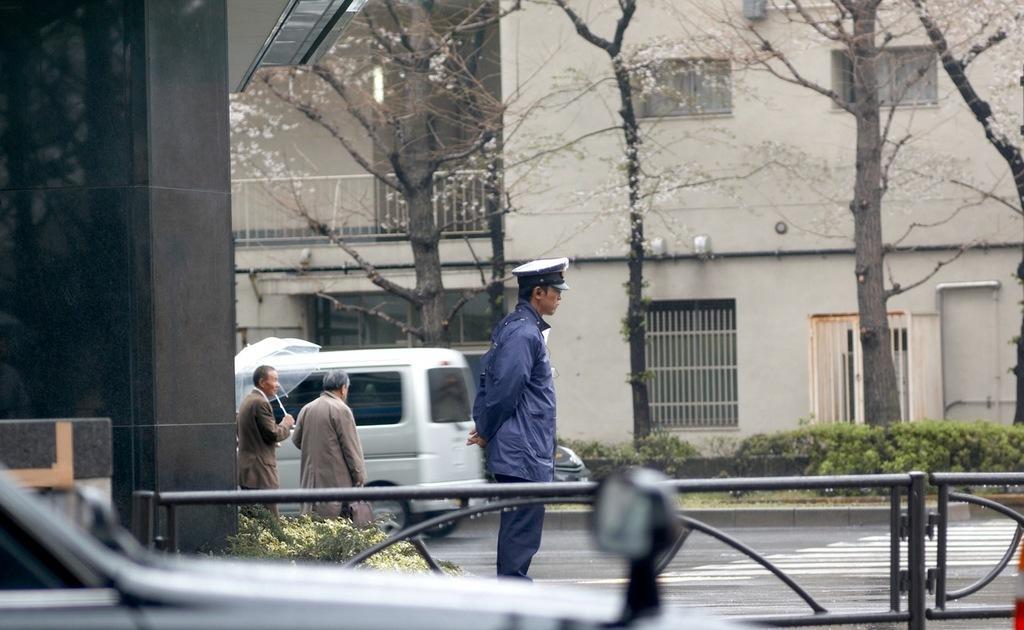In one or two sentences, can you explain what this image depicts? This picture is clicked outside. In the foreground we can see an object seems to be the vehicle and we can see the metal rods and group of persons and we can see the plants, trees, buildings, railings, vehicle, umbrella and some other objects. 